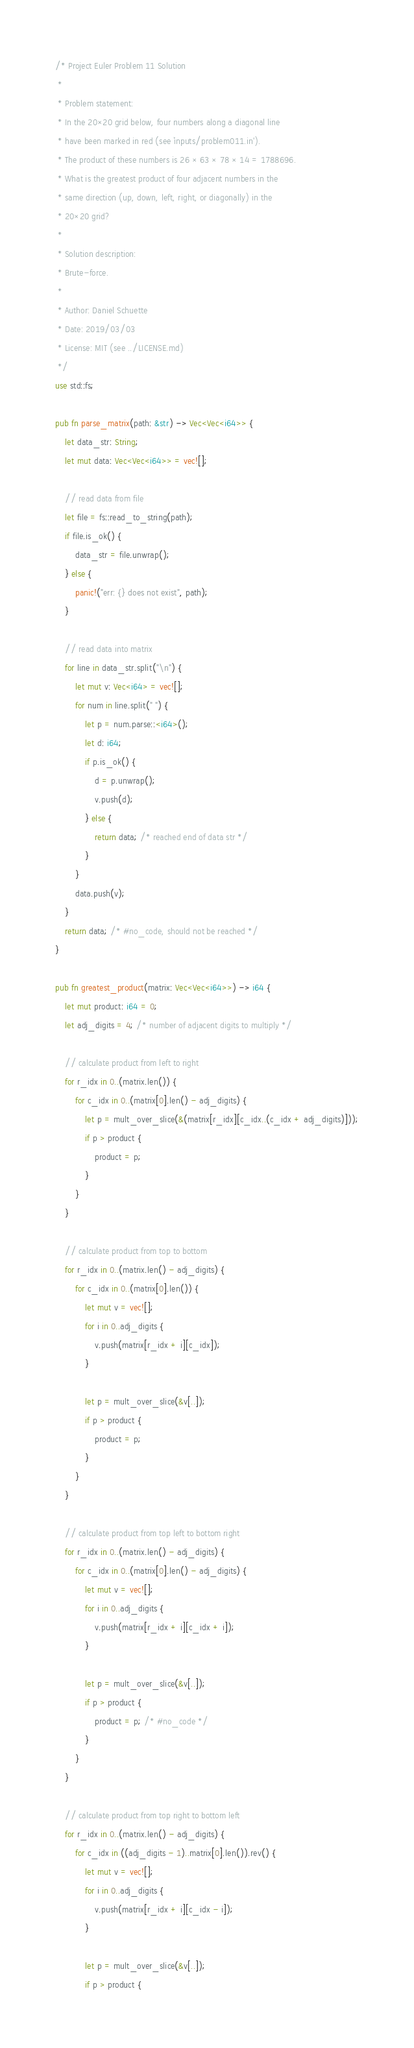<code> <loc_0><loc_0><loc_500><loc_500><_Rust_>/* Project Euler Problem 11 Solution
 *
 * Problem statement:
 * In the 20×20 grid below, four numbers along a diagonal line
 * have been marked in red (see `inputs/problem011.in').
 * The product of these numbers is 26 × 63 × 78 × 14 = 1788696.
 * What is the greatest product of four adjacent numbers in the
 * same direction (up, down, left, right, or diagonally) in the
 * 20×20 grid?
 *
 * Solution description:
 * Brute-force.
 *
 * Author: Daniel Schuette
 * Date: 2019/03/03
 * License: MIT (see ../LICENSE.md)
 */
use std::fs;

pub fn parse_matrix(path: &str) -> Vec<Vec<i64>> {
    let data_str: String;
    let mut data: Vec<Vec<i64>> = vec![];

    // read data from file
    let file = fs::read_to_string(path);
    if file.is_ok() {
        data_str = file.unwrap();
    } else {
        panic!("err: {} does not exist", path);
    }

    // read data into matrix
    for line in data_str.split("\n") {
        let mut v: Vec<i64> = vec![];
        for num in line.split(" ") {
            let p = num.parse::<i64>();
            let d: i64;
            if p.is_ok() {
                d = p.unwrap();
                v.push(d);
            } else {
                return data; /* reached end of data str */
            }
        }
        data.push(v);
    }
    return data; /* #no_code, should not be reached */
}

pub fn greatest_product(matrix: Vec<Vec<i64>>) -> i64 {
    let mut product: i64 = 0;
    let adj_digits = 4; /* number of adjacent digits to multiply */

    // calculate product from left to right
    for r_idx in 0..(matrix.len()) {
        for c_idx in 0..(matrix[0].len() - adj_digits) {
            let p = mult_over_slice(&(matrix[r_idx][c_idx..(c_idx + adj_digits)]));
            if p > product {
                product = p;
            }
        }
    }

    // calculate product from top to bottom
    for r_idx in 0..(matrix.len() - adj_digits) {
        for c_idx in 0..(matrix[0].len()) {
            let mut v = vec![];
            for i in 0..adj_digits {
                v.push(matrix[r_idx + i][c_idx]);
            }

            let p = mult_over_slice(&v[..]);
            if p > product {
                product = p;
            }
        }
    }

    // calculate product from top left to bottom right
    for r_idx in 0..(matrix.len() - adj_digits) {
        for c_idx in 0..(matrix[0].len() - adj_digits) {
            let mut v = vec![];
            for i in 0..adj_digits {
                v.push(matrix[r_idx + i][c_idx + i]);
            }

            let p = mult_over_slice(&v[..]);
            if p > product {
                product = p; /* #no_code */
            }
        }
    }

    // calculate product from top right to bottom left
    for r_idx in 0..(matrix.len() - adj_digits) {
        for c_idx in ((adj_digits - 1)..matrix[0].len()).rev() {
            let mut v = vec![];
            for i in 0..adj_digits {
                v.push(matrix[r_idx + i][c_idx - i]);
            }

            let p = mult_over_slice(&v[..]);
            if p > product {</code> 